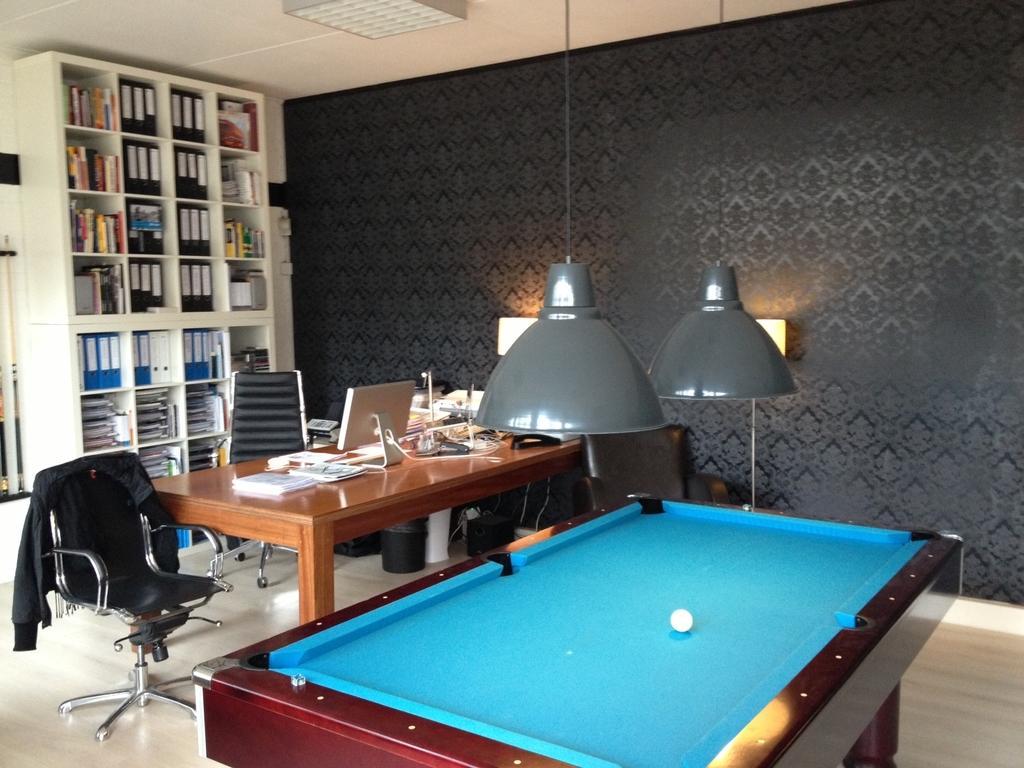Can you describe this image briefly? This Image is clicked in a room where there is a table, snooker pool, chairs, racks, and in the racks there are so many and files and books. On the table there is a book and there are papers, computer,pens. There are lights in the middle. There is a ball on Snooker Pool. 